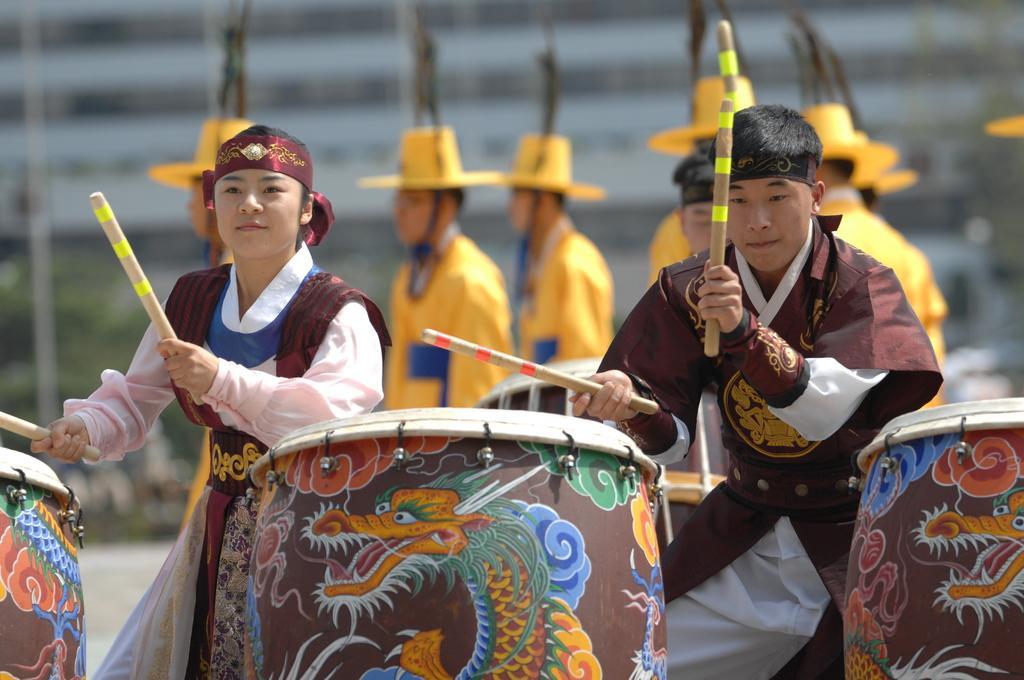How would you summarize this image in a sentence or two? In the picture we can see some people are holding a sticks and performing a play and we can see some people are wearing a yellow dress and yellow hats and we can see some drugs which are designed with paintings. 